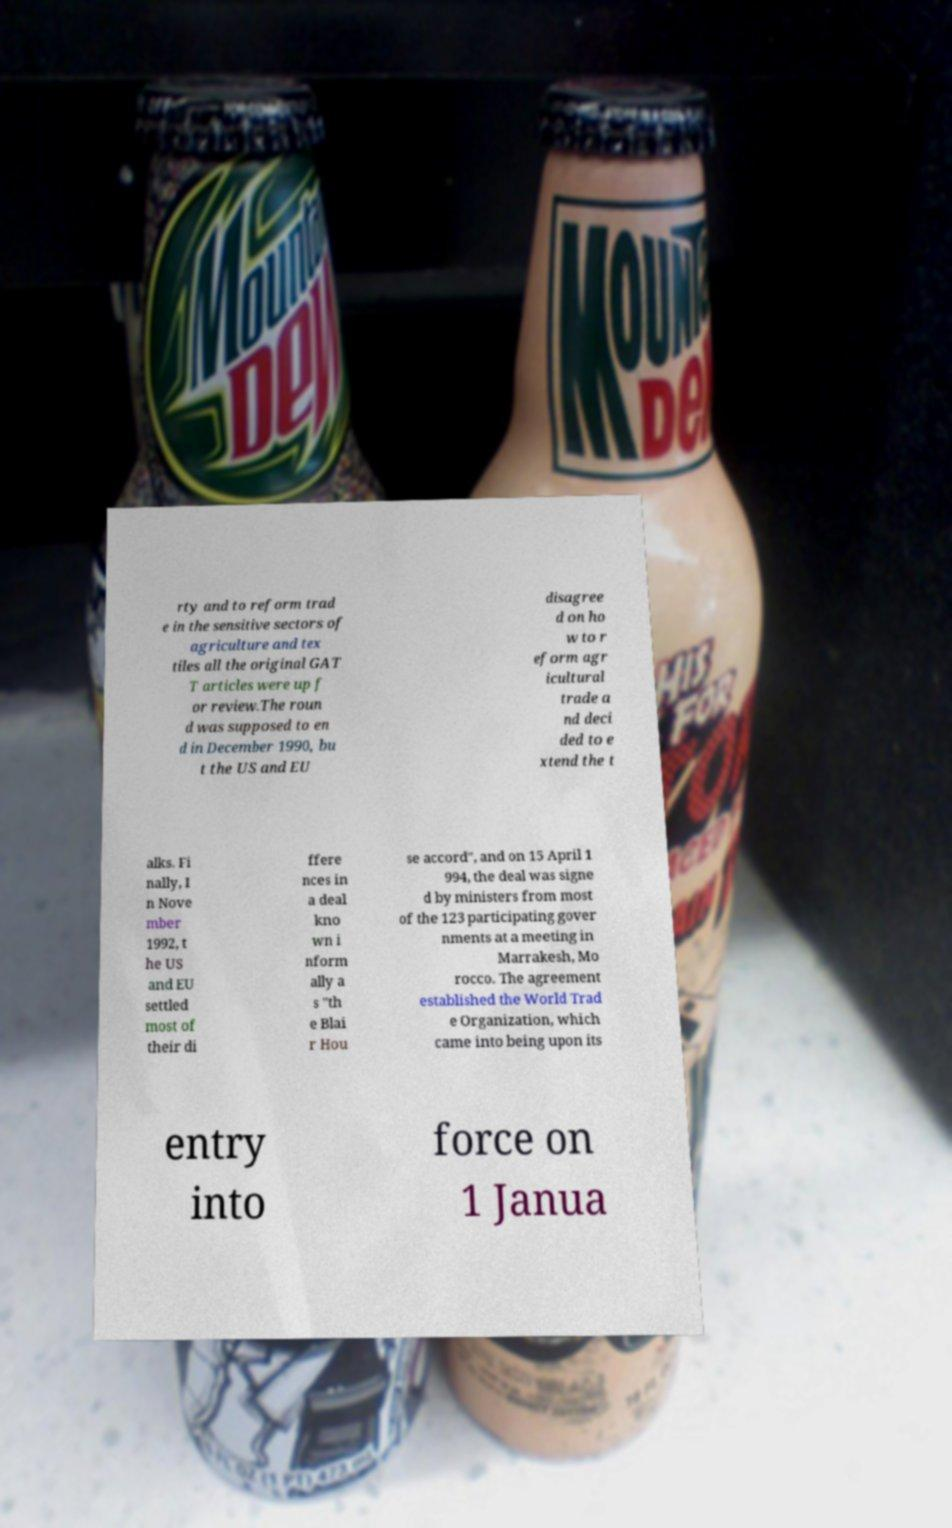What messages or text are displayed in this image? I need them in a readable, typed format. rty and to reform trad e in the sensitive sectors of agriculture and tex tiles all the original GAT T articles were up f or review.The roun d was supposed to en d in December 1990, bu t the US and EU disagree d on ho w to r eform agr icultural trade a nd deci ded to e xtend the t alks. Fi nally, I n Nove mber 1992, t he US and EU settled most of their di ffere nces in a deal kno wn i nform ally a s "th e Blai r Hou se accord", and on 15 April 1 994, the deal was signe d by ministers from most of the 123 participating gover nments at a meeting in Marrakesh, Mo rocco. The agreement established the World Trad e Organization, which came into being upon its entry into force on 1 Janua 